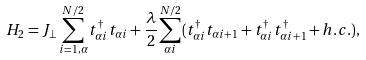Convert formula to latex. <formula><loc_0><loc_0><loc_500><loc_500>H _ { 2 } = J _ { \perp } \sum ^ { N / 2 } _ { i = 1 , \alpha } t ^ { \dagger } _ { \alpha i } t _ { \alpha i } + \frac { \lambda } { 2 } \sum _ { \alpha i } ^ { N / 2 } ( t ^ { \dagger } _ { \alpha i } t _ { \alpha i + 1 } + t _ { \alpha i } ^ { \dagger } t ^ { \dagger } _ { \alpha i + 1 } + h . c . ) ,</formula> 